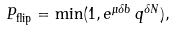Convert formula to latex. <formula><loc_0><loc_0><loc_500><loc_500>P _ { \text {flip} } = \min ( 1 , e ^ { \mu \delta b } \, q ^ { \delta N } ) ,</formula> 